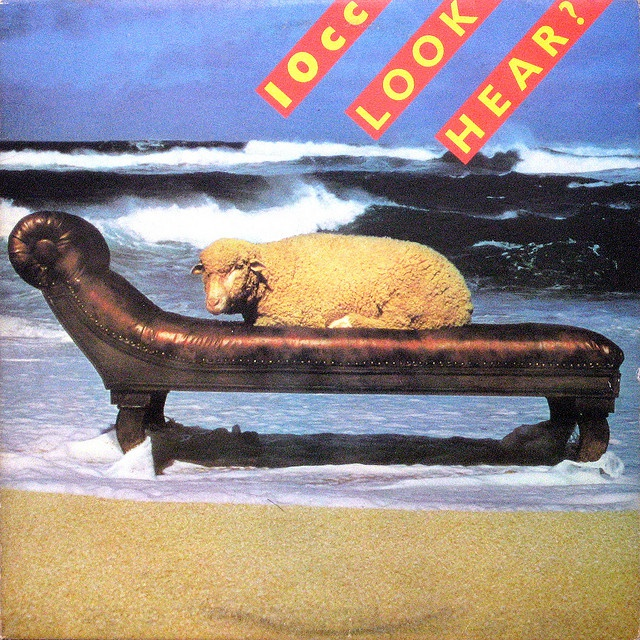Describe the objects in this image and their specific colors. I can see couch in white, black, gray, and maroon tones, bed in white, black, gray, and maroon tones, and sheep in white, khaki, and tan tones in this image. 